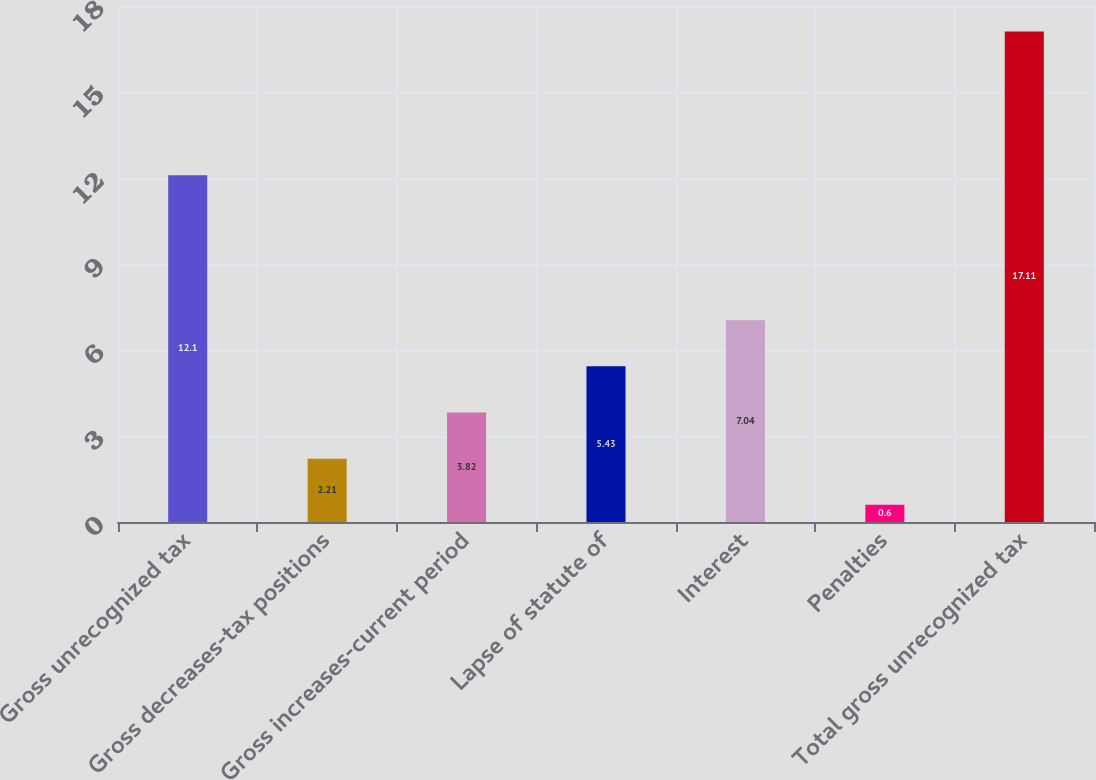<chart> <loc_0><loc_0><loc_500><loc_500><bar_chart><fcel>Gross unrecognized tax<fcel>Gross decreases-tax positions<fcel>Gross increases-current period<fcel>Lapse of statute of<fcel>Interest<fcel>Penalties<fcel>Total gross unrecognized tax<nl><fcel>12.1<fcel>2.21<fcel>3.82<fcel>5.43<fcel>7.04<fcel>0.6<fcel>17.11<nl></chart> 